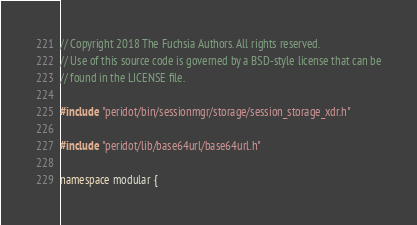<code> <loc_0><loc_0><loc_500><loc_500><_C++_>// Copyright 2018 The Fuchsia Authors. All rights reserved.
// Use of this source code is governed by a BSD-style license that can be
// found in the LICENSE file.

#include "peridot/bin/sessionmgr/storage/session_storage_xdr.h"

#include "peridot/lib/base64url/base64url.h"

namespace modular {
</code> 